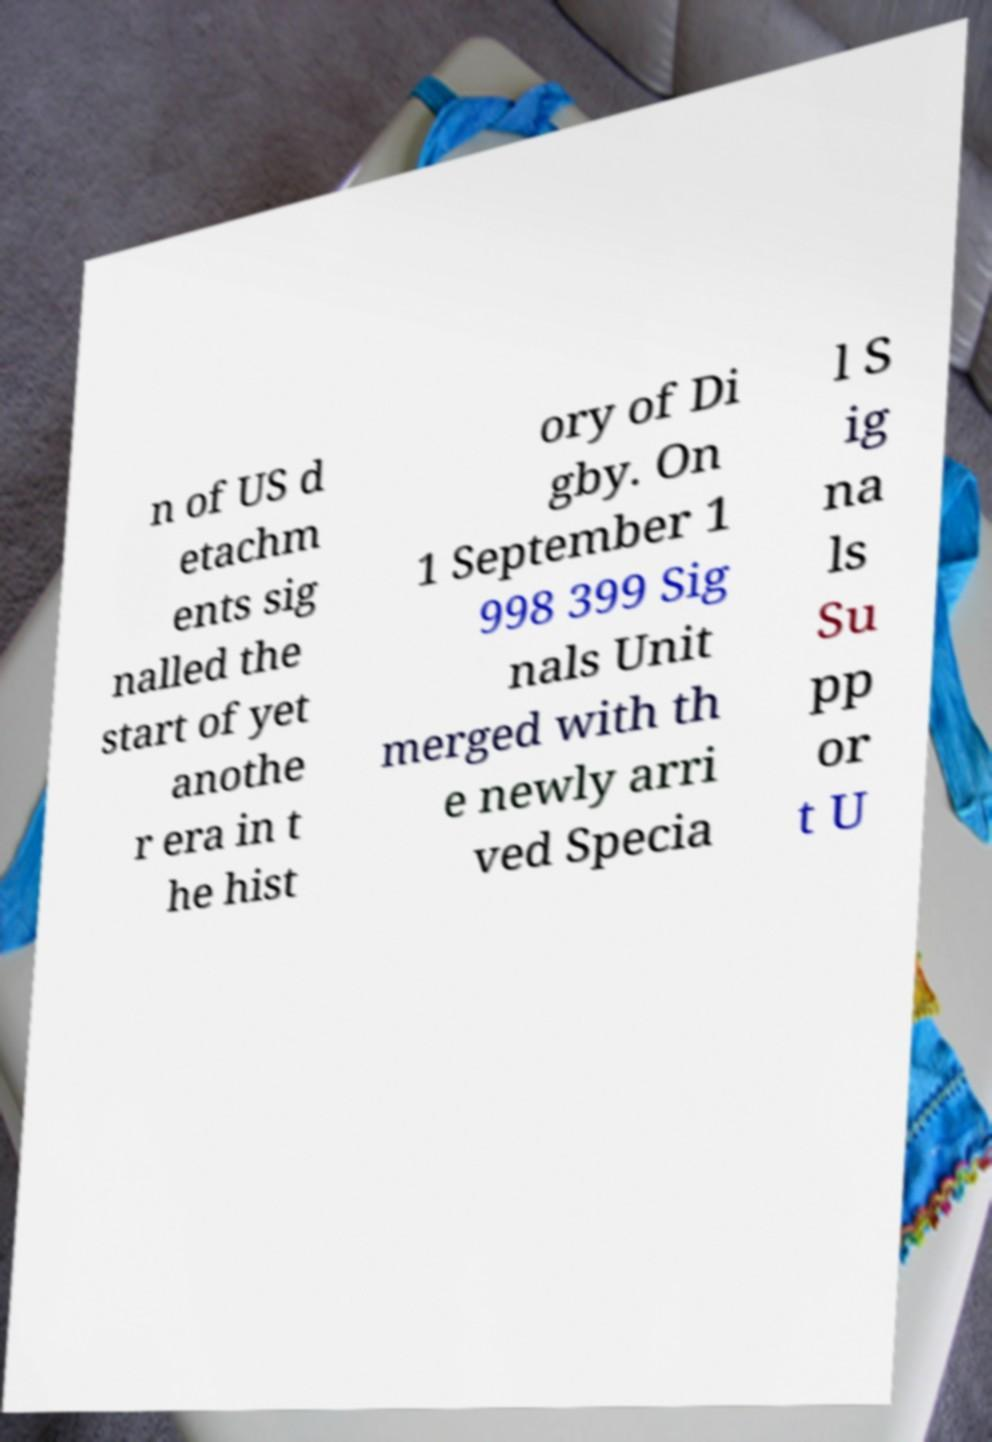For documentation purposes, I need the text within this image transcribed. Could you provide that? n of US d etachm ents sig nalled the start of yet anothe r era in t he hist ory of Di gby. On 1 September 1 998 399 Sig nals Unit merged with th e newly arri ved Specia l S ig na ls Su pp or t U 